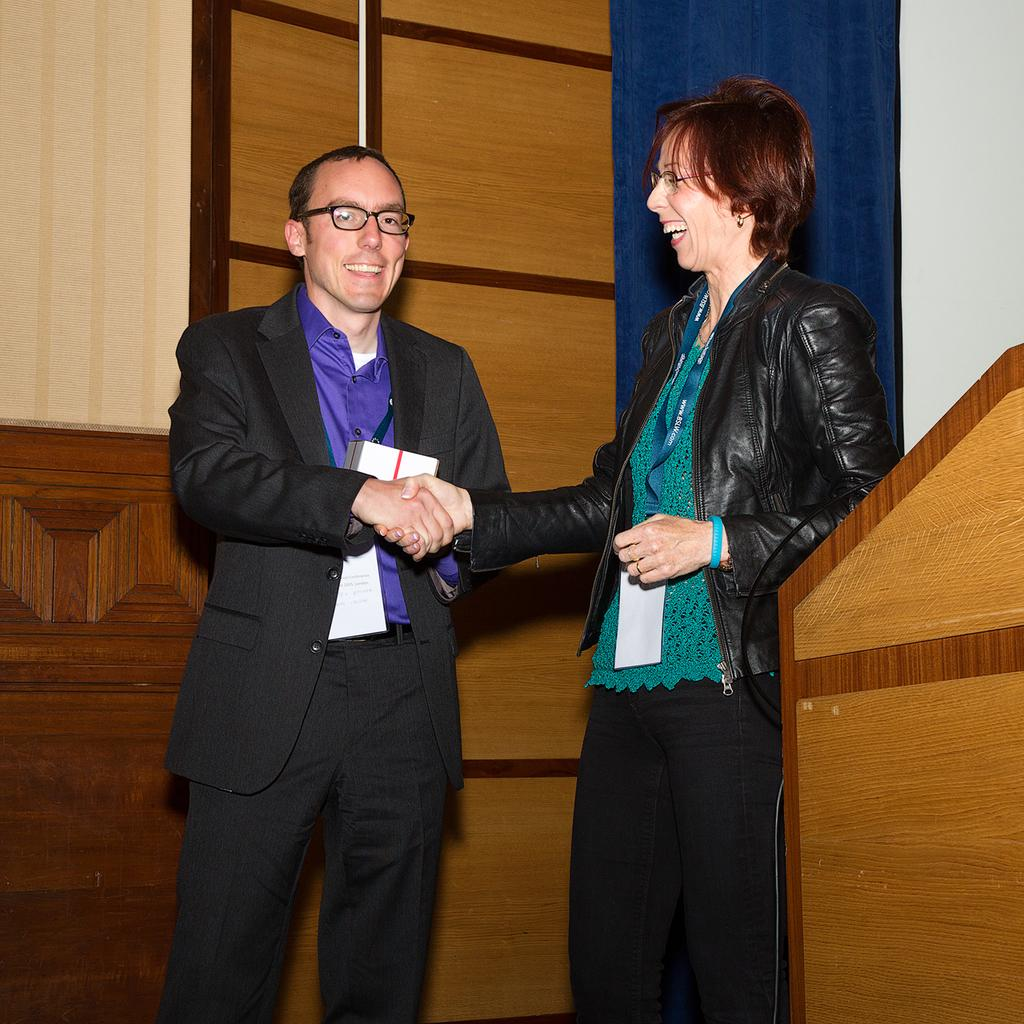How many people are in the image? There are two persons in the image. What are the two persons doing in the image? The two persons are standing and smiling, and they are shaking hands. What can be seen behind the two persons? There is a podium and a wooden wall in the image. What type of machine is being measured for errors in the image? There is no machine present in the image, and therefore no measurement or error checking is taking place. 